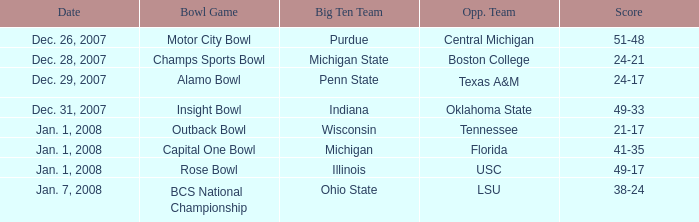What was the score of the Insight Bowl? 49-33. 